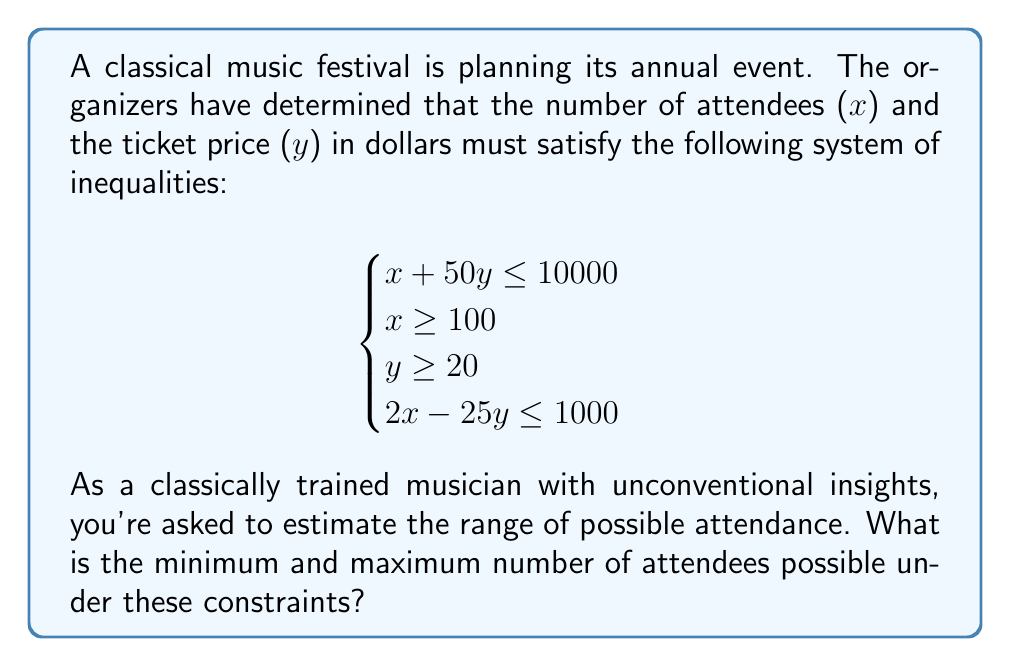Teach me how to tackle this problem. Let's approach this step-by-step:

1) First, we need to find the points of intersection for these inequalities. We'll focus on the equations that directly involve x:

   $x + 50y = 10000$ (1)
   $x = 100$ (2)
   $2x - 25y = 1000$ (3)

2) To find the minimum x, we need to find the leftmost point of the feasible region. This will occur at the intersection of (2) and (3):

   $2(100) - 25y = 1000$
   $200 - 25y = 1000$
   $-25y = 800$
   $y = -32$

   However, $y \geq 20$, so this point is not in our feasible region. The minimum x will thus occur at $x = 100$ and $y = 20$.

3) To find the maximum x, we need to find the rightmost point of the feasible region. This will occur at the intersection of (1) and (3):

   $x + 50y = 10000$ (1)
   $2x - 25y = 1000$ (3)

   Multiplying (3) by 2 and subtracting from (1):

   $2x + 100y = 20000$
   $4x - 50y = 2000$
   $150y = 18000$
   $y = 120$

   Substituting back into (1):

   $x + 50(120) = 10000$
   $x = 4000$

4) We need to check if this point satisfies $y \geq 20$, which it does.

Therefore, the minimum number of attendees is 100, and the maximum is 4000.
Answer: 100 to 4000 attendees 